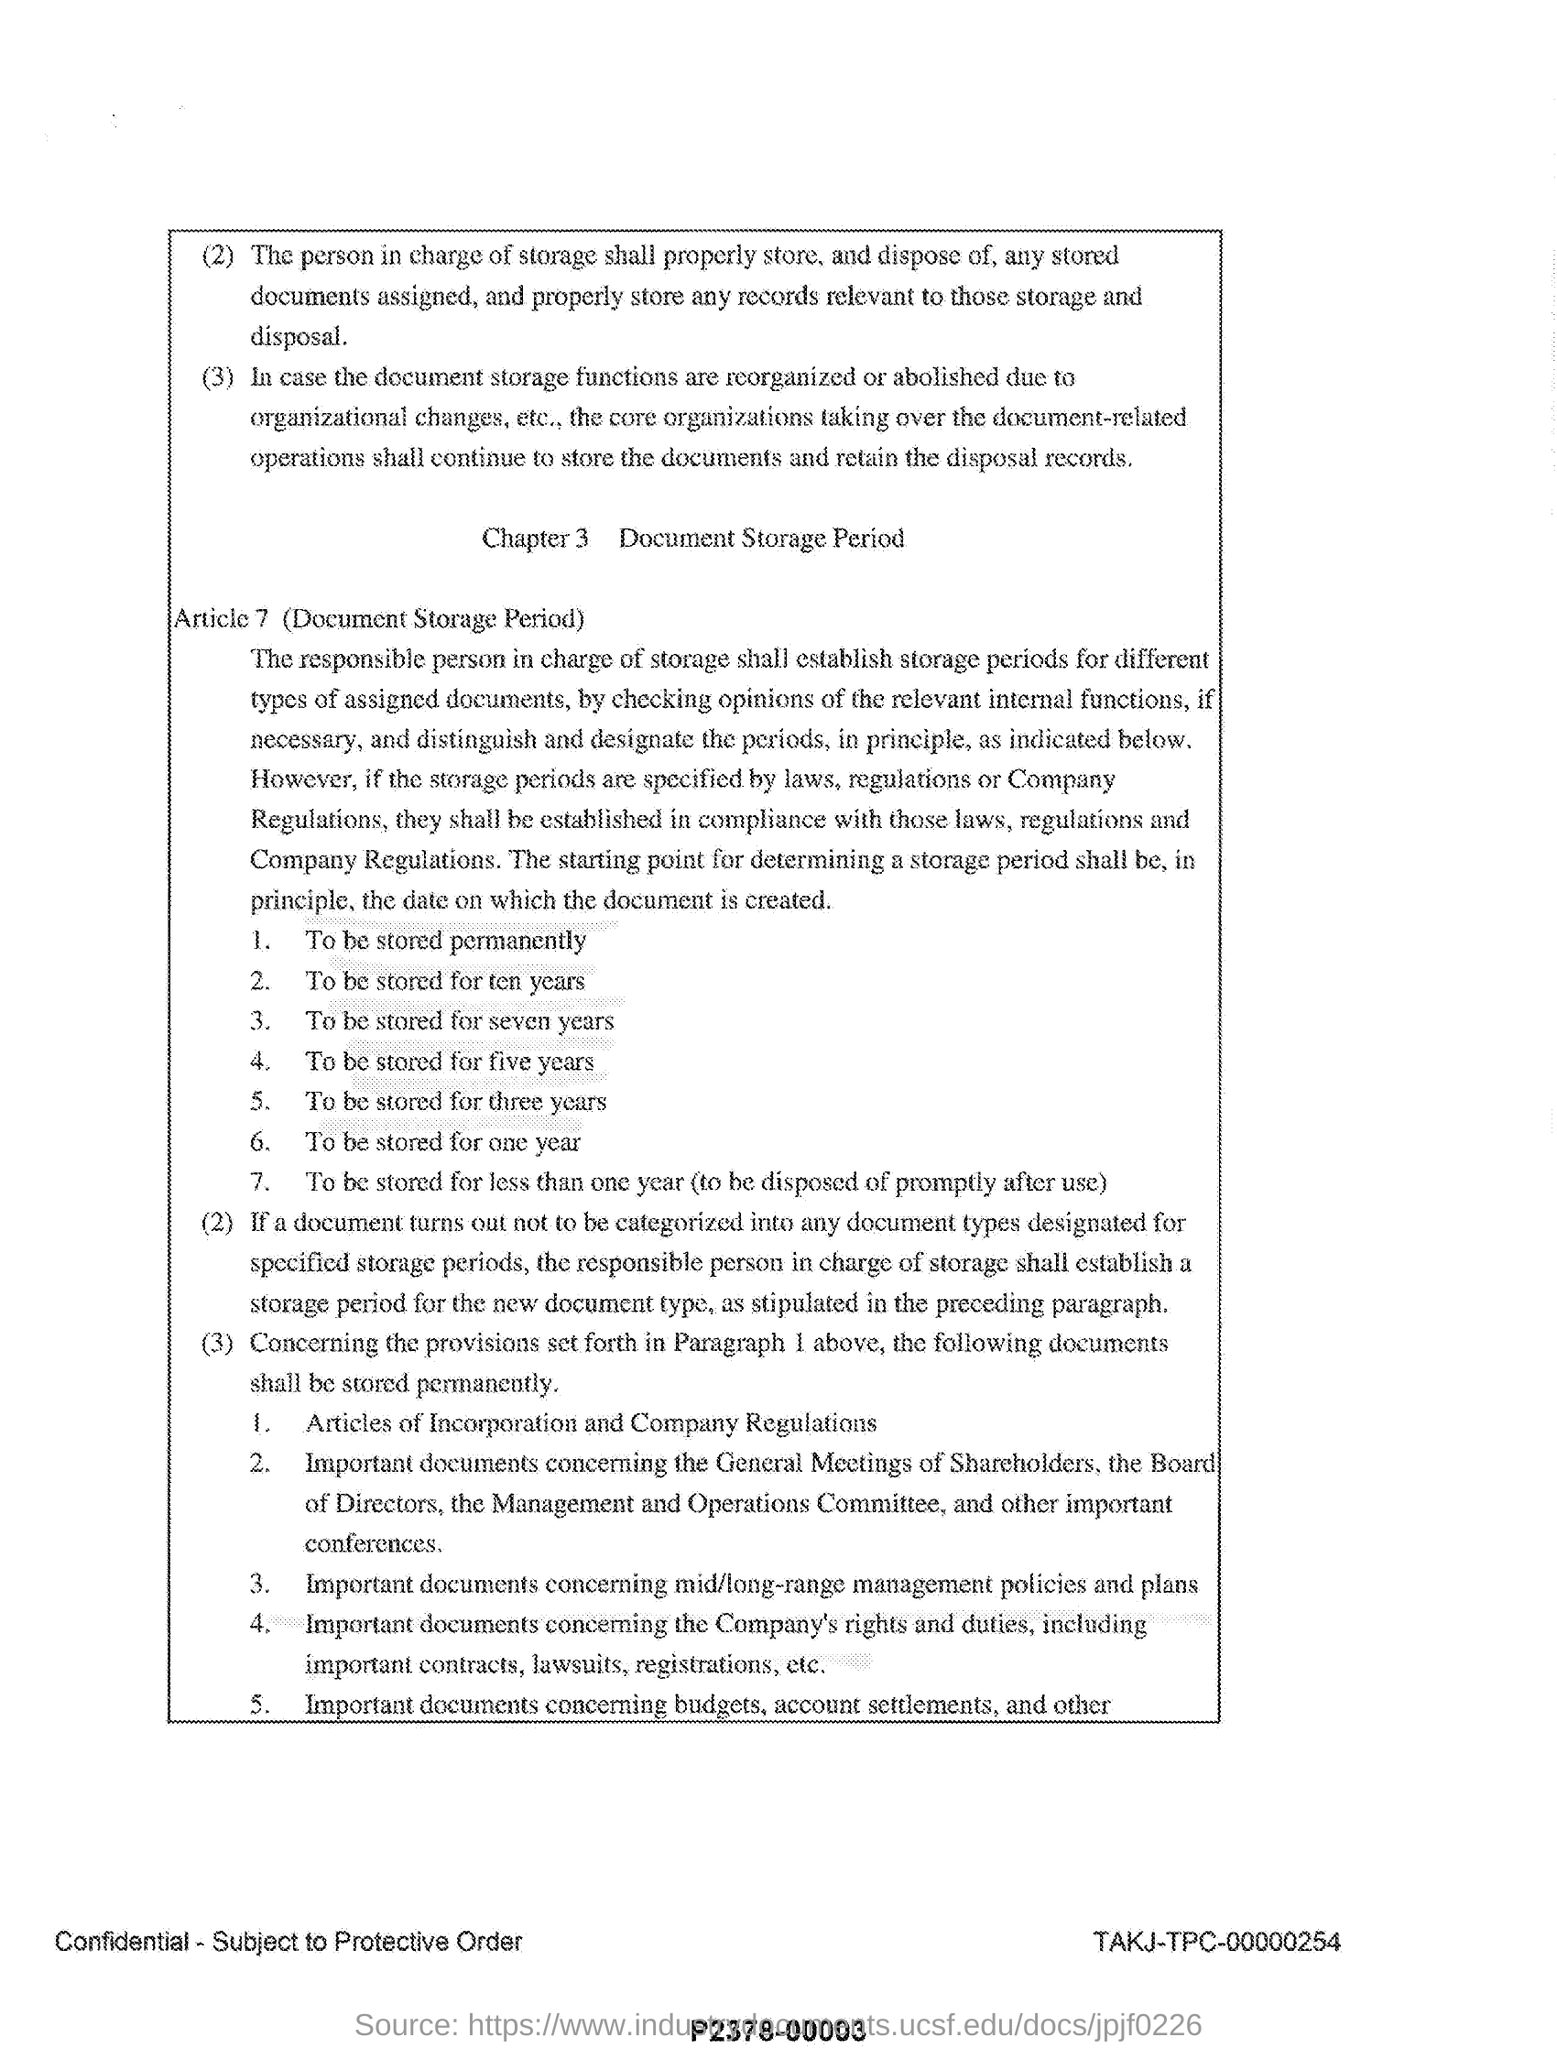What is the title of chapter 3?
Provide a short and direct response. Document storage period. What is the "document storage period " article number?
Give a very brief answer. 7. Mention the second point listed under the article 7(document storage period)?
Keep it short and to the point. To be stored for ten years. 